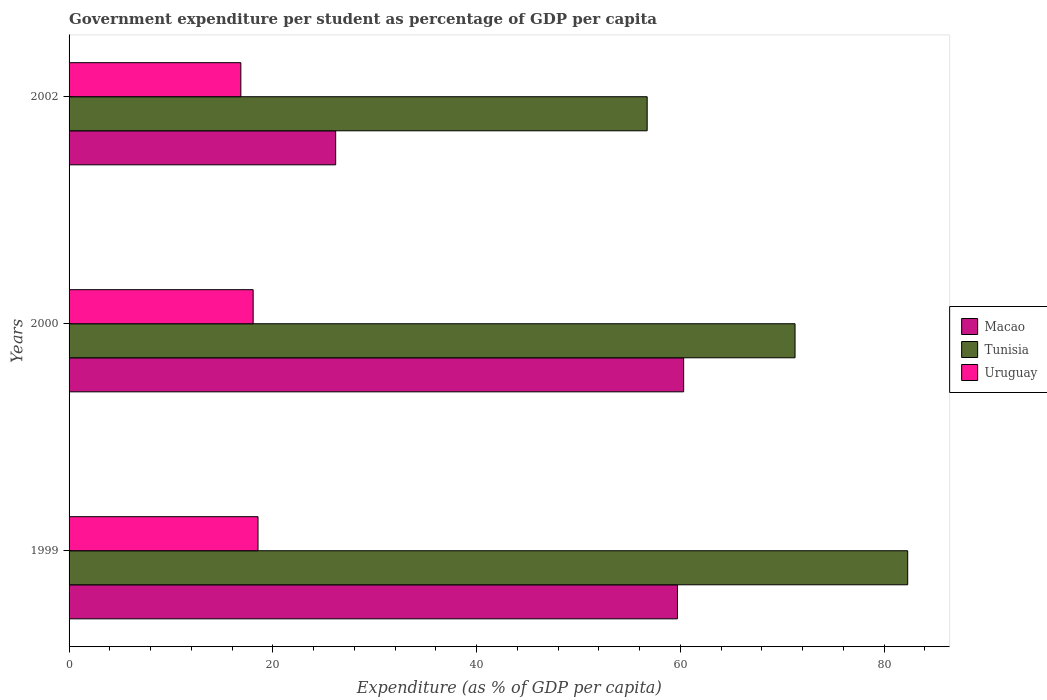How many groups of bars are there?
Offer a very short reply. 3. Are the number of bars per tick equal to the number of legend labels?
Your answer should be compact. Yes. How many bars are there on the 1st tick from the top?
Offer a very short reply. 3. How many bars are there on the 1st tick from the bottom?
Your response must be concise. 3. What is the label of the 2nd group of bars from the top?
Offer a very short reply. 2000. In how many cases, is the number of bars for a given year not equal to the number of legend labels?
Provide a succinct answer. 0. What is the percentage of expenditure per student in Uruguay in 1999?
Make the answer very short. 18.55. Across all years, what is the maximum percentage of expenditure per student in Macao?
Offer a terse response. 60.32. Across all years, what is the minimum percentage of expenditure per student in Uruguay?
Make the answer very short. 16.86. What is the total percentage of expenditure per student in Uruguay in the graph?
Offer a very short reply. 53.47. What is the difference between the percentage of expenditure per student in Tunisia in 1999 and that in 2000?
Ensure brevity in your answer.  11.06. What is the difference between the percentage of expenditure per student in Uruguay in 2000 and the percentage of expenditure per student in Tunisia in 1999?
Make the answer very short. -64.24. What is the average percentage of expenditure per student in Uruguay per year?
Provide a short and direct response. 17.82. In the year 2000, what is the difference between the percentage of expenditure per student in Tunisia and percentage of expenditure per student in Macao?
Keep it short and to the point. 10.93. What is the ratio of the percentage of expenditure per student in Uruguay in 2000 to that in 2002?
Provide a short and direct response. 1.07. Is the difference between the percentage of expenditure per student in Tunisia in 1999 and 2000 greater than the difference between the percentage of expenditure per student in Macao in 1999 and 2000?
Give a very brief answer. Yes. What is the difference between the highest and the second highest percentage of expenditure per student in Macao?
Offer a terse response. 0.61. What is the difference between the highest and the lowest percentage of expenditure per student in Macao?
Provide a succinct answer. 34.16. Is the sum of the percentage of expenditure per student in Tunisia in 1999 and 2002 greater than the maximum percentage of expenditure per student in Macao across all years?
Keep it short and to the point. Yes. What does the 2nd bar from the top in 1999 represents?
Your answer should be compact. Tunisia. What does the 3rd bar from the bottom in 2002 represents?
Your answer should be compact. Uruguay. Is it the case that in every year, the sum of the percentage of expenditure per student in Macao and percentage of expenditure per student in Uruguay is greater than the percentage of expenditure per student in Tunisia?
Offer a terse response. No. How many bars are there?
Provide a succinct answer. 9. Are all the bars in the graph horizontal?
Ensure brevity in your answer.  Yes. How many years are there in the graph?
Your answer should be very brief. 3. How many legend labels are there?
Keep it short and to the point. 3. What is the title of the graph?
Your answer should be very brief. Government expenditure per student as percentage of GDP per capita. What is the label or title of the X-axis?
Provide a short and direct response. Expenditure (as % of GDP per capita). What is the label or title of the Y-axis?
Keep it short and to the point. Years. What is the Expenditure (as % of GDP per capita) of Macao in 1999?
Ensure brevity in your answer.  59.72. What is the Expenditure (as % of GDP per capita) in Tunisia in 1999?
Provide a succinct answer. 82.31. What is the Expenditure (as % of GDP per capita) of Uruguay in 1999?
Give a very brief answer. 18.55. What is the Expenditure (as % of GDP per capita) in Macao in 2000?
Make the answer very short. 60.32. What is the Expenditure (as % of GDP per capita) in Tunisia in 2000?
Give a very brief answer. 71.26. What is the Expenditure (as % of GDP per capita) of Uruguay in 2000?
Make the answer very short. 18.07. What is the Expenditure (as % of GDP per capita) in Macao in 2002?
Your answer should be very brief. 26.17. What is the Expenditure (as % of GDP per capita) of Tunisia in 2002?
Ensure brevity in your answer.  56.74. What is the Expenditure (as % of GDP per capita) in Uruguay in 2002?
Make the answer very short. 16.86. Across all years, what is the maximum Expenditure (as % of GDP per capita) in Macao?
Provide a succinct answer. 60.32. Across all years, what is the maximum Expenditure (as % of GDP per capita) of Tunisia?
Ensure brevity in your answer.  82.31. Across all years, what is the maximum Expenditure (as % of GDP per capita) in Uruguay?
Your answer should be very brief. 18.55. Across all years, what is the minimum Expenditure (as % of GDP per capita) in Macao?
Make the answer very short. 26.17. Across all years, what is the minimum Expenditure (as % of GDP per capita) in Tunisia?
Your answer should be very brief. 56.74. Across all years, what is the minimum Expenditure (as % of GDP per capita) of Uruguay?
Your response must be concise. 16.86. What is the total Expenditure (as % of GDP per capita) of Macao in the graph?
Make the answer very short. 146.2. What is the total Expenditure (as % of GDP per capita) of Tunisia in the graph?
Provide a succinct answer. 210.31. What is the total Expenditure (as % of GDP per capita) in Uruguay in the graph?
Provide a succinct answer. 53.47. What is the difference between the Expenditure (as % of GDP per capita) in Macao in 1999 and that in 2000?
Provide a short and direct response. -0.61. What is the difference between the Expenditure (as % of GDP per capita) of Tunisia in 1999 and that in 2000?
Provide a succinct answer. 11.06. What is the difference between the Expenditure (as % of GDP per capita) in Uruguay in 1999 and that in 2000?
Give a very brief answer. 0.48. What is the difference between the Expenditure (as % of GDP per capita) in Macao in 1999 and that in 2002?
Ensure brevity in your answer.  33.55. What is the difference between the Expenditure (as % of GDP per capita) of Tunisia in 1999 and that in 2002?
Ensure brevity in your answer.  25.57. What is the difference between the Expenditure (as % of GDP per capita) of Uruguay in 1999 and that in 2002?
Offer a terse response. 1.69. What is the difference between the Expenditure (as % of GDP per capita) in Macao in 2000 and that in 2002?
Your answer should be very brief. 34.16. What is the difference between the Expenditure (as % of GDP per capita) of Tunisia in 2000 and that in 2002?
Keep it short and to the point. 14.51. What is the difference between the Expenditure (as % of GDP per capita) of Uruguay in 2000 and that in 2002?
Ensure brevity in your answer.  1.21. What is the difference between the Expenditure (as % of GDP per capita) in Macao in 1999 and the Expenditure (as % of GDP per capita) in Tunisia in 2000?
Offer a very short reply. -11.54. What is the difference between the Expenditure (as % of GDP per capita) in Macao in 1999 and the Expenditure (as % of GDP per capita) in Uruguay in 2000?
Provide a short and direct response. 41.65. What is the difference between the Expenditure (as % of GDP per capita) of Tunisia in 1999 and the Expenditure (as % of GDP per capita) of Uruguay in 2000?
Your response must be concise. 64.24. What is the difference between the Expenditure (as % of GDP per capita) in Macao in 1999 and the Expenditure (as % of GDP per capita) in Tunisia in 2002?
Provide a succinct answer. 2.97. What is the difference between the Expenditure (as % of GDP per capita) in Macao in 1999 and the Expenditure (as % of GDP per capita) in Uruguay in 2002?
Offer a terse response. 42.86. What is the difference between the Expenditure (as % of GDP per capita) of Tunisia in 1999 and the Expenditure (as % of GDP per capita) of Uruguay in 2002?
Your answer should be very brief. 65.45. What is the difference between the Expenditure (as % of GDP per capita) of Macao in 2000 and the Expenditure (as % of GDP per capita) of Tunisia in 2002?
Provide a short and direct response. 3.58. What is the difference between the Expenditure (as % of GDP per capita) in Macao in 2000 and the Expenditure (as % of GDP per capita) in Uruguay in 2002?
Make the answer very short. 43.46. What is the difference between the Expenditure (as % of GDP per capita) in Tunisia in 2000 and the Expenditure (as % of GDP per capita) in Uruguay in 2002?
Provide a short and direct response. 54.4. What is the average Expenditure (as % of GDP per capita) of Macao per year?
Your answer should be compact. 48.73. What is the average Expenditure (as % of GDP per capita) in Tunisia per year?
Provide a short and direct response. 70.1. What is the average Expenditure (as % of GDP per capita) in Uruguay per year?
Give a very brief answer. 17.82. In the year 1999, what is the difference between the Expenditure (as % of GDP per capita) of Macao and Expenditure (as % of GDP per capita) of Tunisia?
Make the answer very short. -22.6. In the year 1999, what is the difference between the Expenditure (as % of GDP per capita) of Macao and Expenditure (as % of GDP per capita) of Uruguay?
Your answer should be compact. 41.17. In the year 1999, what is the difference between the Expenditure (as % of GDP per capita) in Tunisia and Expenditure (as % of GDP per capita) in Uruguay?
Keep it short and to the point. 63.77. In the year 2000, what is the difference between the Expenditure (as % of GDP per capita) in Macao and Expenditure (as % of GDP per capita) in Tunisia?
Provide a short and direct response. -10.93. In the year 2000, what is the difference between the Expenditure (as % of GDP per capita) in Macao and Expenditure (as % of GDP per capita) in Uruguay?
Your answer should be very brief. 42.25. In the year 2000, what is the difference between the Expenditure (as % of GDP per capita) in Tunisia and Expenditure (as % of GDP per capita) in Uruguay?
Your answer should be very brief. 53.19. In the year 2002, what is the difference between the Expenditure (as % of GDP per capita) of Macao and Expenditure (as % of GDP per capita) of Tunisia?
Provide a succinct answer. -30.58. In the year 2002, what is the difference between the Expenditure (as % of GDP per capita) in Macao and Expenditure (as % of GDP per capita) in Uruguay?
Provide a short and direct response. 9.31. In the year 2002, what is the difference between the Expenditure (as % of GDP per capita) of Tunisia and Expenditure (as % of GDP per capita) of Uruguay?
Offer a very short reply. 39.88. What is the ratio of the Expenditure (as % of GDP per capita) of Macao in 1999 to that in 2000?
Your answer should be compact. 0.99. What is the ratio of the Expenditure (as % of GDP per capita) of Tunisia in 1999 to that in 2000?
Provide a short and direct response. 1.16. What is the ratio of the Expenditure (as % of GDP per capita) of Uruguay in 1999 to that in 2000?
Make the answer very short. 1.03. What is the ratio of the Expenditure (as % of GDP per capita) of Macao in 1999 to that in 2002?
Offer a very short reply. 2.28. What is the ratio of the Expenditure (as % of GDP per capita) in Tunisia in 1999 to that in 2002?
Keep it short and to the point. 1.45. What is the ratio of the Expenditure (as % of GDP per capita) in Uruguay in 1999 to that in 2002?
Your response must be concise. 1.1. What is the ratio of the Expenditure (as % of GDP per capita) in Macao in 2000 to that in 2002?
Your answer should be compact. 2.31. What is the ratio of the Expenditure (as % of GDP per capita) in Tunisia in 2000 to that in 2002?
Offer a very short reply. 1.26. What is the ratio of the Expenditure (as % of GDP per capita) in Uruguay in 2000 to that in 2002?
Offer a terse response. 1.07. What is the difference between the highest and the second highest Expenditure (as % of GDP per capita) in Macao?
Ensure brevity in your answer.  0.61. What is the difference between the highest and the second highest Expenditure (as % of GDP per capita) of Tunisia?
Make the answer very short. 11.06. What is the difference between the highest and the second highest Expenditure (as % of GDP per capita) of Uruguay?
Give a very brief answer. 0.48. What is the difference between the highest and the lowest Expenditure (as % of GDP per capita) of Macao?
Provide a succinct answer. 34.16. What is the difference between the highest and the lowest Expenditure (as % of GDP per capita) in Tunisia?
Your answer should be compact. 25.57. What is the difference between the highest and the lowest Expenditure (as % of GDP per capita) of Uruguay?
Ensure brevity in your answer.  1.69. 